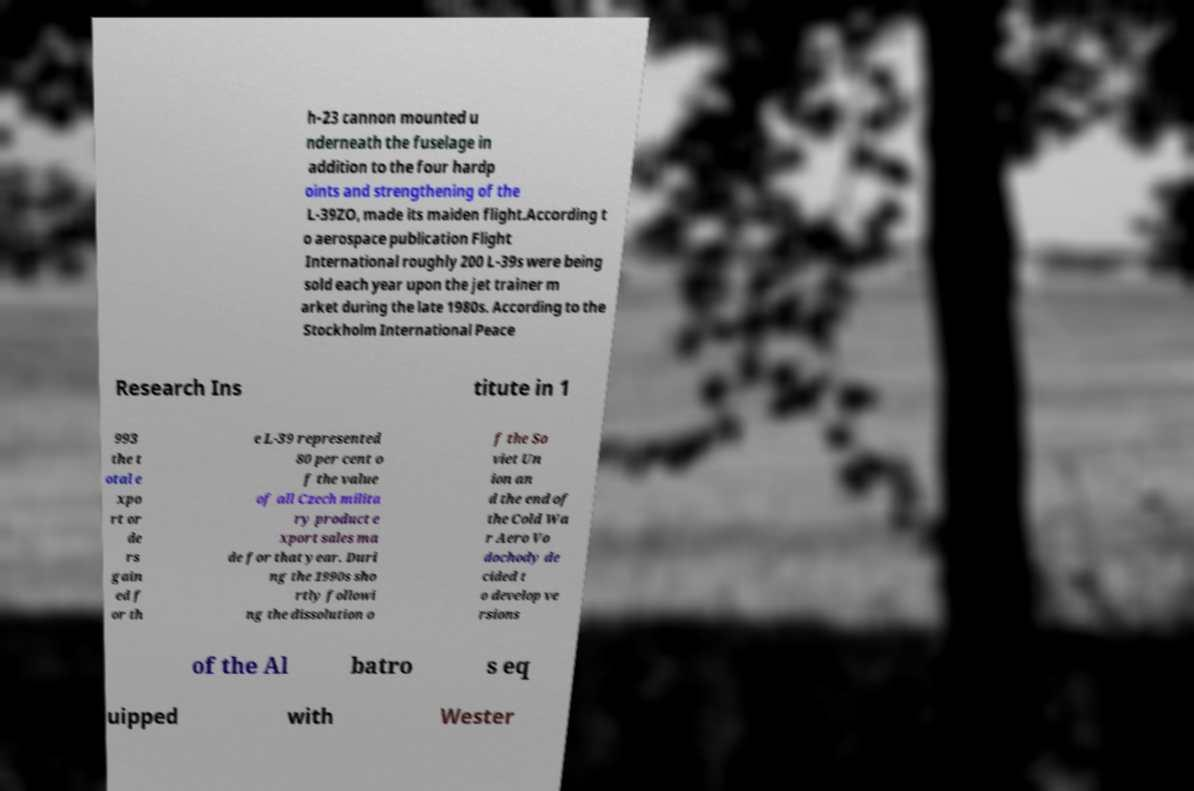Can you read and provide the text displayed in the image?This photo seems to have some interesting text. Can you extract and type it out for me? h-23 cannon mounted u nderneath the fuselage in addition to the four hardp oints and strengthening of the L-39ZO, made its maiden flight.According t o aerospace publication Flight International roughly 200 L-39s were being sold each year upon the jet trainer m arket during the late 1980s. According to the Stockholm International Peace Research Ins titute in 1 993 the t otal e xpo rt or de rs gain ed f or th e L-39 represented 80 per cent o f the value of all Czech milita ry product e xport sales ma de for that year. Duri ng the 1990s sho rtly followi ng the dissolution o f the So viet Un ion an d the end of the Cold Wa r Aero Vo dochody de cided t o develop ve rsions of the Al batro s eq uipped with Wester 